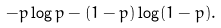Convert formula to latex. <formula><loc_0><loc_0><loc_500><loc_500>- p \log p - ( 1 - p ) \log ( 1 - p ) .</formula> 